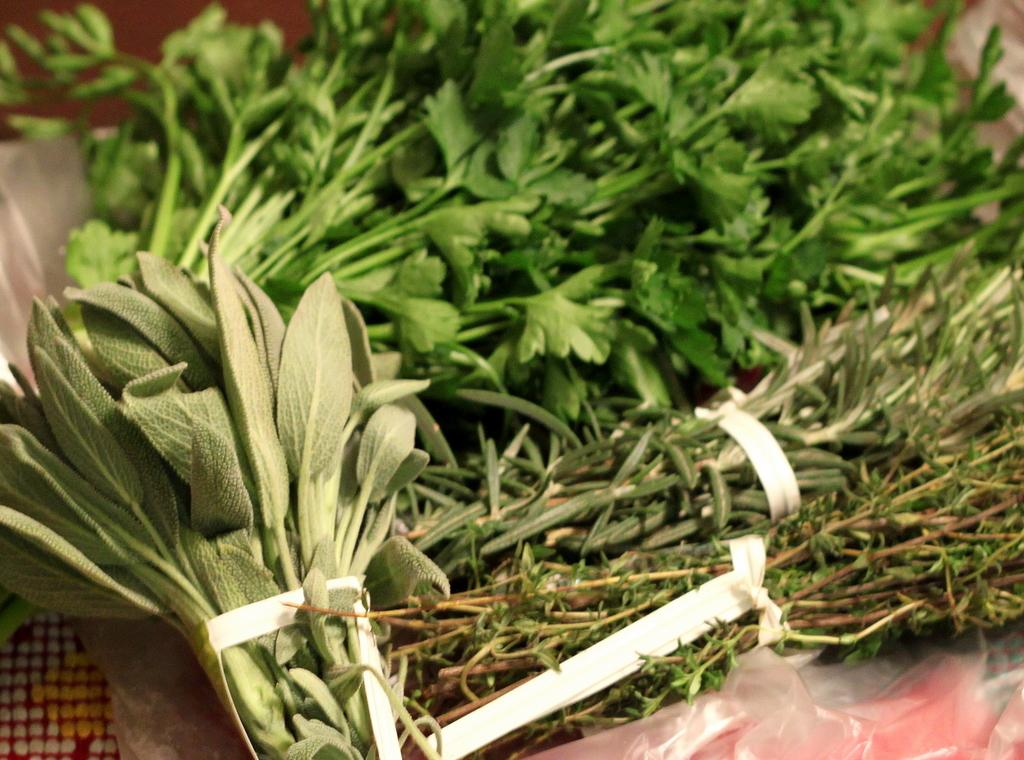What can be observed in the image? There are different types of leaves in the image. Can you describe the leaves in more detail? Unfortunately, the facts provided do not give specific details about the leaves. However, we can observe that there are multiple types of leaves present. What might be the context or setting of the image? Based on the presence of leaves, it is likely that the image was taken in a natural setting, such as a forest or park. How much was the payment for the peace treaty in the image? There is no payment or peace treaty present in the image; it only contains different types of leaves. 